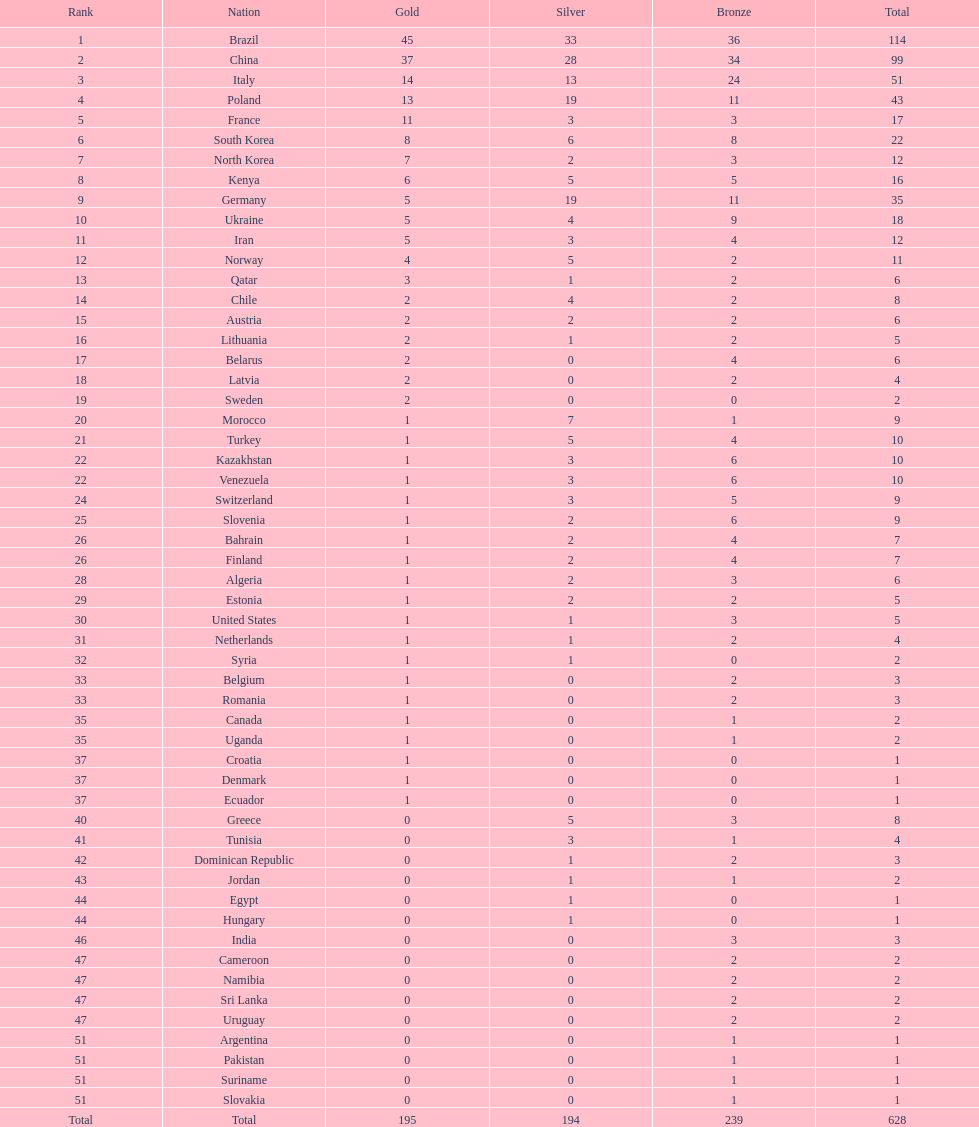Can you give me this table as a dict? {'header': ['Rank', 'Nation', 'Gold', 'Silver', 'Bronze', 'Total'], 'rows': [['1', 'Brazil', '45', '33', '36', '114'], ['2', 'China', '37', '28', '34', '99'], ['3', 'Italy', '14', '13', '24', '51'], ['4', 'Poland', '13', '19', '11', '43'], ['5', 'France', '11', '3', '3', '17'], ['6', 'South Korea', '8', '6', '8', '22'], ['7', 'North Korea', '7', '2', '3', '12'], ['8', 'Kenya', '6', '5', '5', '16'], ['9', 'Germany', '5', '19', '11', '35'], ['10', 'Ukraine', '5', '4', '9', '18'], ['11', 'Iran', '5', '3', '4', '12'], ['12', 'Norway', '4', '5', '2', '11'], ['13', 'Qatar', '3', '1', '2', '6'], ['14', 'Chile', '2', '4', '2', '8'], ['15', 'Austria', '2', '2', '2', '6'], ['16', 'Lithuania', '2', '1', '2', '5'], ['17', 'Belarus', '2', '0', '4', '6'], ['18', 'Latvia', '2', '0', '2', '4'], ['19', 'Sweden', '2', '0', '0', '2'], ['20', 'Morocco', '1', '7', '1', '9'], ['21', 'Turkey', '1', '5', '4', '10'], ['22', 'Kazakhstan', '1', '3', '6', '10'], ['22', 'Venezuela', '1', '3', '6', '10'], ['24', 'Switzerland', '1', '3', '5', '9'], ['25', 'Slovenia', '1', '2', '6', '9'], ['26', 'Bahrain', '1', '2', '4', '7'], ['26', 'Finland', '1', '2', '4', '7'], ['28', 'Algeria', '1', '2', '3', '6'], ['29', 'Estonia', '1', '2', '2', '5'], ['30', 'United States', '1', '1', '3', '5'], ['31', 'Netherlands', '1', '1', '2', '4'], ['32', 'Syria', '1', '1', '0', '2'], ['33', 'Belgium', '1', '0', '2', '3'], ['33', 'Romania', '1', '0', '2', '3'], ['35', 'Canada', '1', '0', '1', '2'], ['35', 'Uganda', '1', '0', '1', '2'], ['37', 'Croatia', '1', '0', '0', '1'], ['37', 'Denmark', '1', '0', '0', '1'], ['37', 'Ecuador', '1', '0', '0', '1'], ['40', 'Greece', '0', '5', '3', '8'], ['41', 'Tunisia', '0', '3', '1', '4'], ['42', 'Dominican Republic', '0', '1', '2', '3'], ['43', 'Jordan', '0', '1', '1', '2'], ['44', 'Egypt', '0', '1', '0', '1'], ['44', 'Hungary', '0', '1', '0', '1'], ['46', 'India', '0', '0', '3', '3'], ['47', 'Cameroon', '0', '0', '2', '2'], ['47', 'Namibia', '0', '0', '2', '2'], ['47', 'Sri Lanka', '0', '0', '2', '2'], ['47', 'Uruguay', '0', '0', '2', '2'], ['51', 'Argentina', '0', '0', '1', '1'], ['51', 'Pakistan', '0', '0', '1', '1'], ['51', 'Suriname', '0', '0', '1', '1'], ['51', 'Slovakia', '0', '0', '1', '1'], ['Total', 'Total', '195', '194', '239', '628']]} Who won more gold medals, brazil or china? Brazil. 